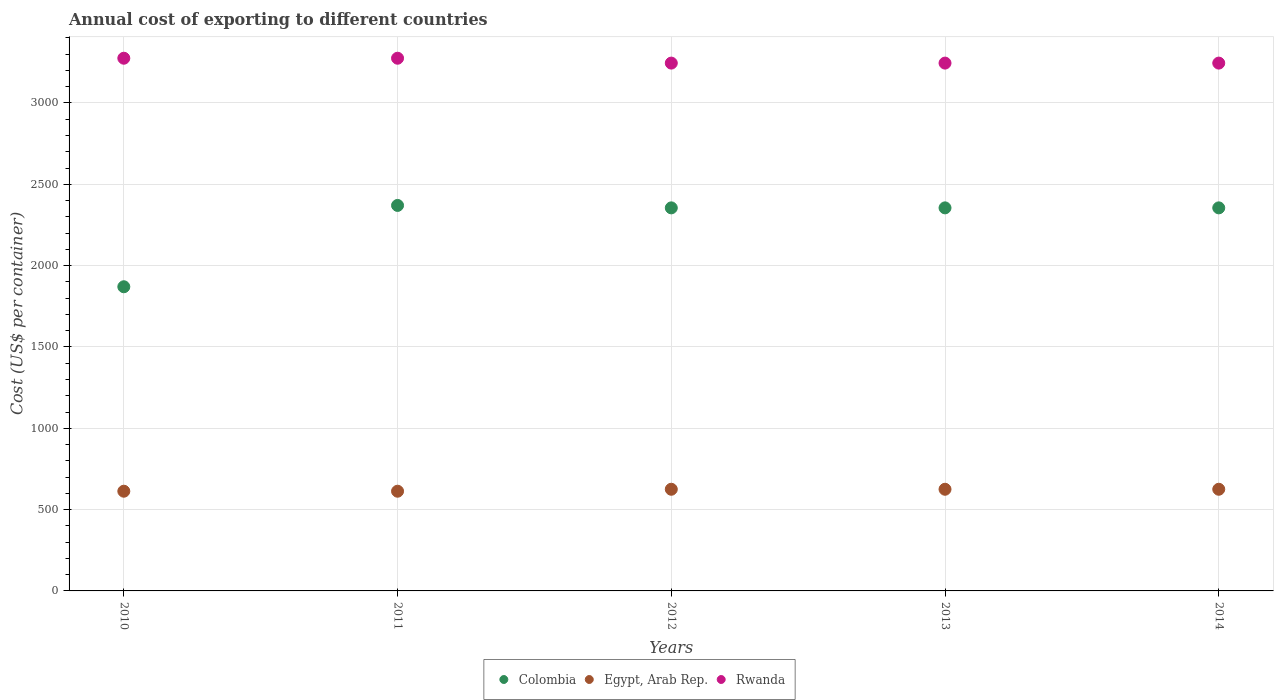Is the number of dotlines equal to the number of legend labels?
Your answer should be compact. Yes. What is the total annual cost of exporting in Egypt, Arab Rep. in 2010?
Keep it short and to the point. 613. Across all years, what is the maximum total annual cost of exporting in Egypt, Arab Rep.?
Make the answer very short. 625. Across all years, what is the minimum total annual cost of exporting in Colombia?
Give a very brief answer. 1870. In which year was the total annual cost of exporting in Rwanda maximum?
Offer a very short reply. 2010. What is the total total annual cost of exporting in Rwanda in the graph?
Your answer should be very brief. 1.63e+04. What is the difference between the total annual cost of exporting in Rwanda in 2011 and that in 2012?
Your answer should be compact. 30. What is the difference between the total annual cost of exporting in Colombia in 2011 and the total annual cost of exporting in Egypt, Arab Rep. in 2012?
Give a very brief answer. 1745. What is the average total annual cost of exporting in Colombia per year?
Provide a short and direct response. 2261. In the year 2013, what is the difference between the total annual cost of exporting in Colombia and total annual cost of exporting in Egypt, Arab Rep.?
Ensure brevity in your answer.  1730. In how many years, is the total annual cost of exporting in Egypt, Arab Rep. greater than 600 US$?
Your response must be concise. 5. What is the ratio of the total annual cost of exporting in Rwanda in 2011 to that in 2013?
Offer a terse response. 1.01. Is the total annual cost of exporting in Colombia in 2012 less than that in 2013?
Your answer should be compact. No. Is the difference between the total annual cost of exporting in Colombia in 2013 and 2014 greater than the difference between the total annual cost of exporting in Egypt, Arab Rep. in 2013 and 2014?
Your response must be concise. No. What is the difference between the highest and the second highest total annual cost of exporting in Egypt, Arab Rep.?
Your response must be concise. 0. What is the difference between the highest and the lowest total annual cost of exporting in Rwanda?
Provide a short and direct response. 30. In how many years, is the total annual cost of exporting in Rwanda greater than the average total annual cost of exporting in Rwanda taken over all years?
Offer a terse response. 2. Is the sum of the total annual cost of exporting in Egypt, Arab Rep. in 2010 and 2011 greater than the maximum total annual cost of exporting in Colombia across all years?
Keep it short and to the point. No. Is it the case that in every year, the sum of the total annual cost of exporting in Colombia and total annual cost of exporting in Egypt, Arab Rep.  is greater than the total annual cost of exporting in Rwanda?
Give a very brief answer. No. Are the values on the major ticks of Y-axis written in scientific E-notation?
Offer a very short reply. No. Does the graph contain any zero values?
Your answer should be very brief. No. Where does the legend appear in the graph?
Your answer should be very brief. Bottom center. How are the legend labels stacked?
Give a very brief answer. Horizontal. What is the title of the graph?
Keep it short and to the point. Annual cost of exporting to different countries. Does "Djibouti" appear as one of the legend labels in the graph?
Ensure brevity in your answer.  No. What is the label or title of the X-axis?
Your response must be concise. Years. What is the label or title of the Y-axis?
Your response must be concise. Cost (US$ per container). What is the Cost (US$ per container) in Colombia in 2010?
Your response must be concise. 1870. What is the Cost (US$ per container) of Egypt, Arab Rep. in 2010?
Provide a succinct answer. 613. What is the Cost (US$ per container) of Rwanda in 2010?
Provide a succinct answer. 3275. What is the Cost (US$ per container) in Colombia in 2011?
Offer a very short reply. 2370. What is the Cost (US$ per container) of Egypt, Arab Rep. in 2011?
Provide a succinct answer. 613. What is the Cost (US$ per container) in Rwanda in 2011?
Ensure brevity in your answer.  3275. What is the Cost (US$ per container) in Colombia in 2012?
Keep it short and to the point. 2355. What is the Cost (US$ per container) in Egypt, Arab Rep. in 2012?
Provide a succinct answer. 625. What is the Cost (US$ per container) in Rwanda in 2012?
Keep it short and to the point. 3245. What is the Cost (US$ per container) of Colombia in 2013?
Your response must be concise. 2355. What is the Cost (US$ per container) in Egypt, Arab Rep. in 2013?
Your answer should be very brief. 625. What is the Cost (US$ per container) of Rwanda in 2013?
Your answer should be very brief. 3245. What is the Cost (US$ per container) of Colombia in 2014?
Provide a short and direct response. 2355. What is the Cost (US$ per container) in Egypt, Arab Rep. in 2014?
Your response must be concise. 625. What is the Cost (US$ per container) in Rwanda in 2014?
Ensure brevity in your answer.  3245. Across all years, what is the maximum Cost (US$ per container) of Colombia?
Keep it short and to the point. 2370. Across all years, what is the maximum Cost (US$ per container) of Egypt, Arab Rep.?
Your answer should be very brief. 625. Across all years, what is the maximum Cost (US$ per container) in Rwanda?
Offer a terse response. 3275. Across all years, what is the minimum Cost (US$ per container) in Colombia?
Offer a very short reply. 1870. Across all years, what is the minimum Cost (US$ per container) in Egypt, Arab Rep.?
Offer a terse response. 613. Across all years, what is the minimum Cost (US$ per container) in Rwanda?
Make the answer very short. 3245. What is the total Cost (US$ per container) in Colombia in the graph?
Offer a very short reply. 1.13e+04. What is the total Cost (US$ per container) of Egypt, Arab Rep. in the graph?
Ensure brevity in your answer.  3101. What is the total Cost (US$ per container) of Rwanda in the graph?
Your answer should be very brief. 1.63e+04. What is the difference between the Cost (US$ per container) of Colombia in 2010 and that in 2011?
Ensure brevity in your answer.  -500. What is the difference between the Cost (US$ per container) of Rwanda in 2010 and that in 2011?
Give a very brief answer. 0. What is the difference between the Cost (US$ per container) in Colombia in 2010 and that in 2012?
Your response must be concise. -485. What is the difference between the Cost (US$ per container) in Colombia in 2010 and that in 2013?
Provide a succinct answer. -485. What is the difference between the Cost (US$ per container) in Colombia in 2010 and that in 2014?
Provide a succinct answer. -485. What is the difference between the Cost (US$ per container) in Egypt, Arab Rep. in 2010 and that in 2014?
Give a very brief answer. -12. What is the difference between the Cost (US$ per container) in Egypt, Arab Rep. in 2011 and that in 2013?
Provide a short and direct response. -12. What is the difference between the Cost (US$ per container) in Egypt, Arab Rep. in 2011 and that in 2014?
Offer a very short reply. -12. What is the difference between the Cost (US$ per container) in Rwanda in 2011 and that in 2014?
Your answer should be very brief. 30. What is the difference between the Cost (US$ per container) of Colombia in 2012 and that in 2013?
Ensure brevity in your answer.  0. What is the difference between the Cost (US$ per container) of Egypt, Arab Rep. in 2012 and that in 2013?
Your answer should be compact. 0. What is the difference between the Cost (US$ per container) in Rwanda in 2012 and that in 2013?
Your answer should be compact. 0. What is the difference between the Cost (US$ per container) of Rwanda in 2013 and that in 2014?
Your answer should be compact. 0. What is the difference between the Cost (US$ per container) of Colombia in 2010 and the Cost (US$ per container) of Egypt, Arab Rep. in 2011?
Provide a succinct answer. 1257. What is the difference between the Cost (US$ per container) of Colombia in 2010 and the Cost (US$ per container) of Rwanda in 2011?
Your answer should be compact. -1405. What is the difference between the Cost (US$ per container) of Egypt, Arab Rep. in 2010 and the Cost (US$ per container) of Rwanda in 2011?
Keep it short and to the point. -2662. What is the difference between the Cost (US$ per container) in Colombia in 2010 and the Cost (US$ per container) in Egypt, Arab Rep. in 2012?
Ensure brevity in your answer.  1245. What is the difference between the Cost (US$ per container) in Colombia in 2010 and the Cost (US$ per container) in Rwanda in 2012?
Keep it short and to the point. -1375. What is the difference between the Cost (US$ per container) in Egypt, Arab Rep. in 2010 and the Cost (US$ per container) in Rwanda in 2012?
Ensure brevity in your answer.  -2632. What is the difference between the Cost (US$ per container) of Colombia in 2010 and the Cost (US$ per container) of Egypt, Arab Rep. in 2013?
Provide a short and direct response. 1245. What is the difference between the Cost (US$ per container) in Colombia in 2010 and the Cost (US$ per container) in Rwanda in 2013?
Your answer should be very brief. -1375. What is the difference between the Cost (US$ per container) of Egypt, Arab Rep. in 2010 and the Cost (US$ per container) of Rwanda in 2013?
Make the answer very short. -2632. What is the difference between the Cost (US$ per container) in Colombia in 2010 and the Cost (US$ per container) in Egypt, Arab Rep. in 2014?
Offer a very short reply. 1245. What is the difference between the Cost (US$ per container) in Colombia in 2010 and the Cost (US$ per container) in Rwanda in 2014?
Your answer should be very brief. -1375. What is the difference between the Cost (US$ per container) of Egypt, Arab Rep. in 2010 and the Cost (US$ per container) of Rwanda in 2014?
Ensure brevity in your answer.  -2632. What is the difference between the Cost (US$ per container) of Colombia in 2011 and the Cost (US$ per container) of Egypt, Arab Rep. in 2012?
Provide a succinct answer. 1745. What is the difference between the Cost (US$ per container) in Colombia in 2011 and the Cost (US$ per container) in Rwanda in 2012?
Offer a very short reply. -875. What is the difference between the Cost (US$ per container) of Egypt, Arab Rep. in 2011 and the Cost (US$ per container) of Rwanda in 2012?
Keep it short and to the point. -2632. What is the difference between the Cost (US$ per container) of Colombia in 2011 and the Cost (US$ per container) of Egypt, Arab Rep. in 2013?
Provide a short and direct response. 1745. What is the difference between the Cost (US$ per container) in Colombia in 2011 and the Cost (US$ per container) in Rwanda in 2013?
Offer a very short reply. -875. What is the difference between the Cost (US$ per container) of Egypt, Arab Rep. in 2011 and the Cost (US$ per container) of Rwanda in 2013?
Offer a very short reply. -2632. What is the difference between the Cost (US$ per container) in Colombia in 2011 and the Cost (US$ per container) in Egypt, Arab Rep. in 2014?
Give a very brief answer. 1745. What is the difference between the Cost (US$ per container) of Colombia in 2011 and the Cost (US$ per container) of Rwanda in 2014?
Keep it short and to the point. -875. What is the difference between the Cost (US$ per container) in Egypt, Arab Rep. in 2011 and the Cost (US$ per container) in Rwanda in 2014?
Provide a short and direct response. -2632. What is the difference between the Cost (US$ per container) of Colombia in 2012 and the Cost (US$ per container) of Egypt, Arab Rep. in 2013?
Your answer should be compact. 1730. What is the difference between the Cost (US$ per container) of Colombia in 2012 and the Cost (US$ per container) of Rwanda in 2013?
Offer a terse response. -890. What is the difference between the Cost (US$ per container) of Egypt, Arab Rep. in 2012 and the Cost (US$ per container) of Rwanda in 2013?
Ensure brevity in your answer.  -2620. What is the difference between the Cost (US$ per container) in Colombia in 2012 and the Cost (US$ per container) in Egypt, Arab Rep. in 2014?
Your answer should be compact. 1730. What is the difference between the Cost (US$ per container) in Colombia in 2012 and the Cost (US$ per container) in Rwanda in 2014?
Offer a very short reply. -890. What is the difference between the Cost (US$ per container) in Egypt, Arab Rep. in 2012 and the Cost (US$ per container) in Rwanda in 2014?
Your answer should be compact. -2620. What is the difference between the Cost (US$ per container) in Colombia in 2013 and the Cost (US$ per container) in Egypt, Arab Rep. in 2014?
Make the answer very short. 1730. What is the difference between the Cost (US$ per container) in Colombia in 2013 and the Cost (US$ per container) in Rwanda in 2014?
Ensure brevity in your answer.  -890. What is the difference between the Cost (US$ per container) in Egypt, Arab Rep. in 2013 and the Cost (US$ per container) in Rwanda in 2014?
Give a very brief answer. -2620. What is the average Cost (US$ per container) of Colombia per year?
Your answer should be very brief. 2261. What is the average Cost (US$ per container) of Egypt, Arab Rep. per year?
Give a very brief answer. 620.2. What is the average Cost (US$ per container) in Rwanda per year?
Keep it short and to the point. 3257. In the year 2010, what is the difference between the Cost (US$ per container) in Colombia and Cost (US$ per container) in Egypt, Arab Rep.?
Keep it short and to the point. 1257. In the year 2010, what is the difference between the Cost (US$ per container) of Colombia and Cost (US$ per container) of Rwanda?
Provide a short and direct response. -1405. In the year 2010, what is the difference between the Cost (US$ per container) in Egypt, Arab Rep. and Cost (US$ per container) in Rwanda?
Your answer should be very brief. -2662. In the year 2011, what is the difference between the Cost (US$ per container) of Colombia and Cost (US$ per container) of Egypt, Arab Rep.?
Provide a succinct answer. 1757. In the year 2011, what is the difference between the Cost (US$ per container) in Colombia and Cost (US$ per container) in Rwanda?
Make the answer very short. -905. In the year 2011, what is the difference between the Cost (US$ per container) in Egypt, Arab Rep. and Cost (US$ per container) in Rwanda?
Your answer should be very brief. -2662. In the year 2012, what is the difference between the Cost (US$ per container) in Colombia and Cost (US$ per container) in Egypt, Arab Rep.?
Provide a succinct answer. 1730. In the year 2012, what is the difference between the Cost (US$ per container) in Colombia and Cost (US$ per container) in Rwanda?
Ensure brevity in your answer.  -890. In the year 2012, what is the difference between the Cost (US$ per container) of Egypt, Arab Rep. and Cost (US$ per container) of Rwanda?
Provide a short and direct response. -2620. In the year 2013, what is the difference between the Cost (US$ per container) of Colombia and Cost (US$ per container) of Egypt, Arab Rep.?
Your response must be concise. 1730. In the year 2013, what is the difference between the Cost (US$ per container) in Colombia and Cost (US$ per container) in Rwanda?
Your response must be concise. -890. In the year 2013, what is the difference between the Cost (US$ per container) of Egypt, Arab Rep. and Cost (US$ per container) of Rwanda?
Make the answer very short. -2620. In the year 2014, what is the difference between the Cost (US$ per container) of Colombia and Cost (US$ per container) of Egypt, Arab Rep.?
Provide a short and direct response. 1730. In the year 2014, what is the difference between the Cost (US$ per container) of Colombia and Cost (US$ per container) of Rwanda?
Keep it short and to the point. -890. In the year 2014, what is the difference between the Cost (US$ per container) in Egypt, Arab Rep. and Cost (US$ per container) in Rwanda?
Your response must be concise. -2620. What is the ratio of the Cost (US$ per container) in Colombia in 2010 to that in 2011?
Ensure brevity in your answer.  0.79. What is the ratio of the Cost (US$ per container) of Rwanda in 2010 to that in 2011?
Ensure brevity in your answer.  1. What is the ratio of the Cost (US$ per container) in Colombia in 2010 to that in 2012?
Ensure brevity in your answer.  0.79. What is the ratio of the Cost (US$ per container) of Egypt, Arab Rep. in 2010 to that in 2012?
Keep it short and to the point. 0.98. What is the ratio of the Cost (US$ per container) of Rwanda in 2010 to that in 2012?
Provide a short and direct response. 1.01. What is the ratio of the Cost (US$ per container) of Colombia in 2010 to that in 2013?
Offer a terse response. 0.79. What is the ratio of the Cost (US$ per container) of Egypt, Arab Rep. in 2010 to that in 2013?
Offer a terse response. 0.98. What is the ratio of the Cost (US$ per container) of Rwanda in 2010 to that in 2013?
Keep it short and to the point. 1.01. What is the ratio of the Cost (US$ per container) of Colombia in 2010 to that in 2014?
Provide a succinct answer. 0.79. What is the ratio of the Cost (US$ per container) of Egypt, Arab Rep. in 2010 to that in 2014?
Ensure brevity in your answer.  0.98. What is the ratio of the Cost (US$ per container) in Rwanda in 2010 to that in 2014?
Keep it short and to the point. 1.01. What is the ratio of the Cost (US$ per container) of Colombia in 2011 to that in 2012?
Offer a terse response. 1.01. What is the ratio of the Cost (US$ per container) of Egypt, Arab Rep. in 2011 to that in 2012?
Your answer should be compact. 0.98. What is the ratio of the Cost (US$ per container) in Rwanda in 2011 to that in 2012?
Provide a short and direct response. 1.01. What is the ratio of the Cost (US$ per container) of Colombia in 2011 to that in 2013?
Your answer should be very brief. 1.01. What is the ratio of the Cost (US$ per container) of Egypt, Arab Rep. in 2011 to that in 2013?
Ensure brevity in your answer.  0.98. What is the ratio of the Cost (US$ per container) of Rwanda in 2011 to that in 2013?
Your response must be concise. 1.01. What is the ratio of the Cost (US$ per container) of Colombia in 2011 to that in 2014?
Your answer should be compact. 1.01. What is the ratio of the Cost (US$ per container) of Egypt, Arab Rep. in 2011 to that in 2014?
Offer a terse response. 0.98. What is the ratio of the Cost (US$ per container) in Rwanda in 2011 to that in 2014?
Offer a very short reply. 1.01. What is the ratio of the Cost (US$ per container) of Colombia in 2012 to that in 2013?
Your response must be concise. 1. What is the ratio of the Cost (US$ per container) of Egypt, Arab Rep. in 2012 to that in 2013?
Make the answer very short. 1. What is the ratio of the Cost (US$ per container) of Rwanda in 2012 to that in 2013?
Your answer should be very brief. 1. What is the ratio of the Cost (US$ per container) in Colombia in 2012 to that in 2014?
Provide a short and direct response. 1. What is the ratio of the Cost (US$ per container) in Egypt, Arab Rep. in 2012 to that in 2014?
Your answer should be compact. 1. What is the ratio of the Cost (US$ per container) of Rwanda in 2012 to that in 2014?
Offer a terse response. 1. What is the ratio of the Cost (US$ per container) in Colombia in 2013 to that in 2014?
Your answer should be very brief. 1. What is the ratio of the Cost (US$ per container) in Egypt, Arab Rep. in 2013 to that in 2014?
Provide a short and direct response. 1. What is the ratio of the Cost (US$ per container) in Rwanda in 2013 to that in 2014?
Make the answer very short. 1. What is the difference between the highest and the second highest Cost (US$ per container) in Colombia?
Provide a succinct answer. 15. What is the difference between the highest and the lowest Cost (US$ per container) in Colombia?
Keep it short and to the point. 500. What is the difference between the highest and the lowest Cost (US$ per container) of Rwanda?
Make the answer very short. 30. 